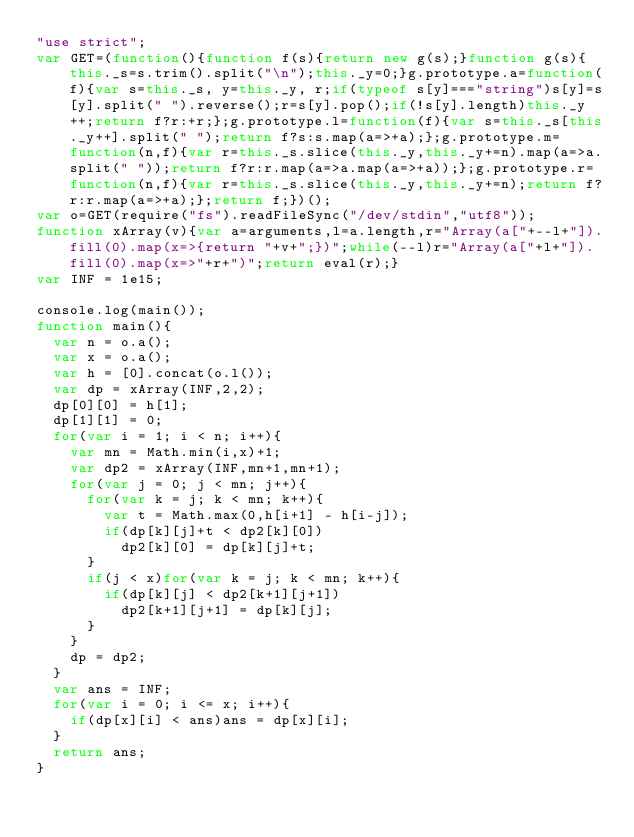Convert code to text. <code><loc_0><loc_0><loc_500><loc_500><_JavaScript_>"use strict";
var GET=(function(){function f(s){return new g(s);}function g(s){this._s=s.trim().split("\n");this._y=0;}g.prototype.a=function(f){var s=this._s, y=this._y, r;if(typeof s[y]==="string")s[y]=s[y].split(" ").reverse();r=s[y].pop();if(!s[y].length)this._y++;return f?r:+r;};g.prototype.l=function(f){var s=this._s[this._y++].split(" ");return f?s:s.map(a=>+a);};g.prototype.m=function(n,f){var r=this._s.slice(this._y,this._y+=n).map(a=>a.split(" "));return f?r:r.map(a=>a.map(a=>+a));};g.prototype.r=function(n,f){var r=this._s.slice(this._y,this._y+=n);return f?r:r.map(a=>+a);};return f;})();
var o=GET(require("fs").readFileSync("/dev/stdin","utf8"));
function xArray(v){var a=arguments,l=a.length,r="Array(a["+--l+"]).fill(0).map(x=>{return "+v+";})";while(--l)r="Array(a["+l+"]).fill(0).map(x=>"+r+")";return eval(r);}
var INF = 1e15;

console.log(main());
function main(){
  var n = o.a();
  var x = o.a();
  var h = [0].concat(o.l());
  var dp = xArray(INF,2,2);
  dp[0][0] = h[1];
  dp[1][1] = 0;
  for(var i = 1; i < n; i++){
    var mn = Math.min(i,x)+1;
    var dp2 = xArray(INF,mn+1,mn+1);
    for(var j = 0; j < mn; j++){
      for(var k = j; k < mn; k++){
        var t = Math.max(0,h[i+1] - h[i-j]);
        if(dp[k][j]+t < dp2[k][0])
          dp2[k][0] = dp[k][j]+t;
      }
      if(j < x)for(var k = j; k < mn; k++){
        if(dp[k][j] < dp2[k+1][j+1])
          dp2[k+1][j+1] = dp[k][j];
      }
    }
    dp = dp2;
  }
  var ans = INF;
  for(var i = 0; i <= x; i++){
    if(dp[x][i] < ans)ans = dp[x][i];
  }
  return ans;
}</code> 